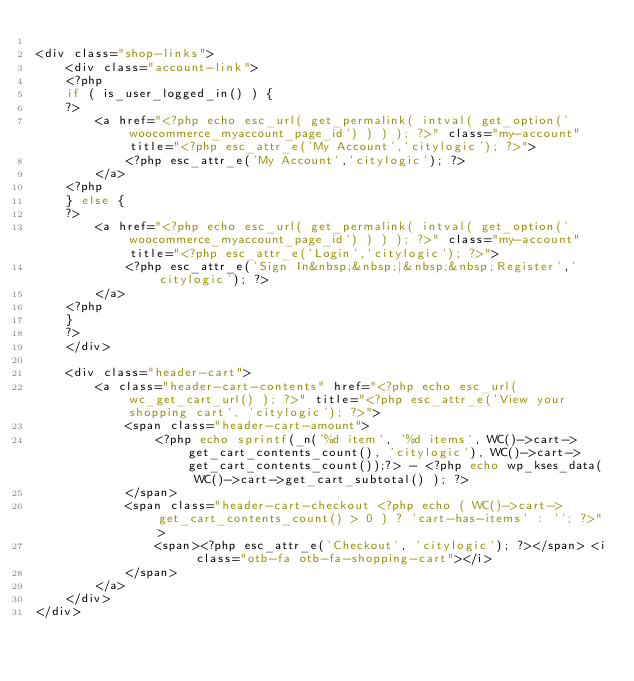<code> <loc_0><loc_0><loc_500><loc_500><_PHP_>
<div class="shop-links">
	<div class="account-link">
	<?php
	if ( is_user_logged_in() ) {
	?>
		<a href="<?php echo esc_url( get_permalink( intval( get_option('woocommerce_myaccount_page_id') ) ) ); ?>" class="my-account" title="<?php esc_attr_e('My Account','citylogic'); ?>">
			<?php esc_attr_e('My Account','citylogic'); ?>
		</a>
	<?php
	} else {
	?>
		<a href="<?php echo esc_url( get_permalink( intval( get_option('woocommerce_myaccount_page_id') ) ) ); ?>" class="my-account" title="<?php esc_attr_e('Login','citylogic'); ?>">
			<?php esc_attr_e('Sign In&nbsp;&nbsp;|&nbsp;&nbsp;Register','citylogic'); ?>
		</a>
	<?php
	}
	?>
	</div>
	
	<div class="header-cart">
		<a class="header-cart-contents" href="<?php echo esc_url( wc_get_cart_url() ); ?>" title="<?php esc_attr_e('View your shopping cart', 'citylogic'); ?>">
			<span class="header-cart-amount">
				<?php echo sprintf(_n('%d item', '%d items', WC()->cart->get_cart_contents_count(), 'citylogic'), WC()->cart->get_cart_contents_count());?> - <?php echo wp_kses_data( WC()->cart->get_cart_subtotal() ); ?>
			</span>
			<span class="header-cart-checkout <?php echo ( WC()->cart->get_cart_contents_count() > 0 ) ? 'cart-has-items' : ''; ?>">
				<span><?php esc_attr_e('Checkout', 'citylogic'); ?></span> <i class="otb-fa otb-fa-shopping-cart"></i>
			</span>
		</a>
	</div>
</div></code> 